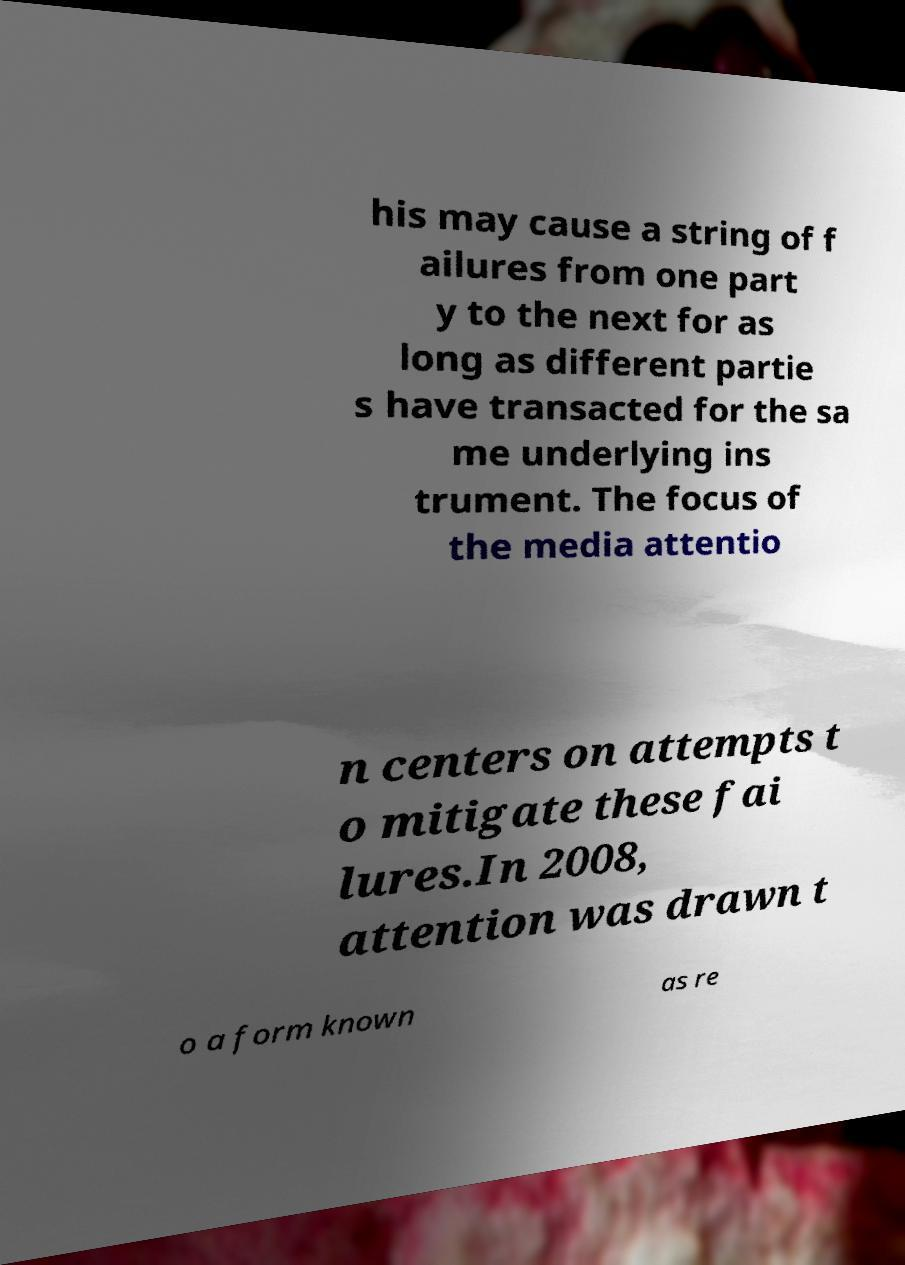Please identify and transcribe the text found in this image. his may cause a string of f ailures from one part y to the next for as long as different partie s have transacted for the sa me underlying ins trument. The focus of the media attentio n centers on attempts t o mitigate these fai lures.In 2008, attention was drawn t o a form known as re 